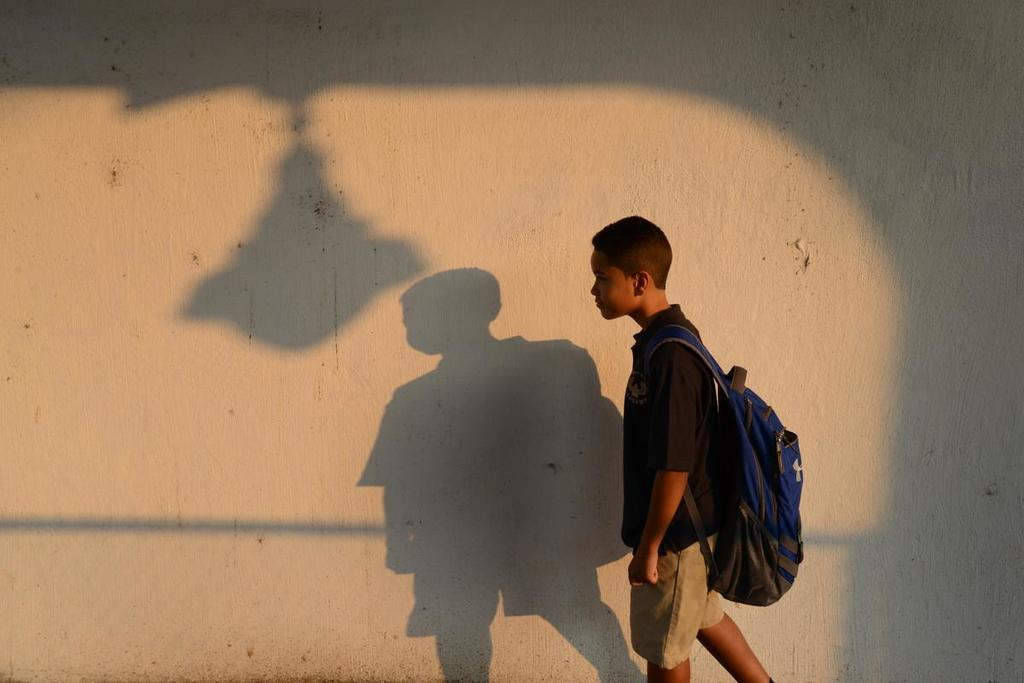What is the main subject in the foreground of the image? There is a boy in the foreground of the image. What is the boy doing in the image? The boy is walking in the image. What is the boy carrying on his back? The boy is wearing a backpack in the image. What can be seen in the background of the image? There is a wall in the background of the image. What is a feature of the wall in the image? Shadows are visible on the wall in the image. What type of lead is the boy holding in his hands in the image? There is no lead visible in the boy's hands in the image. 